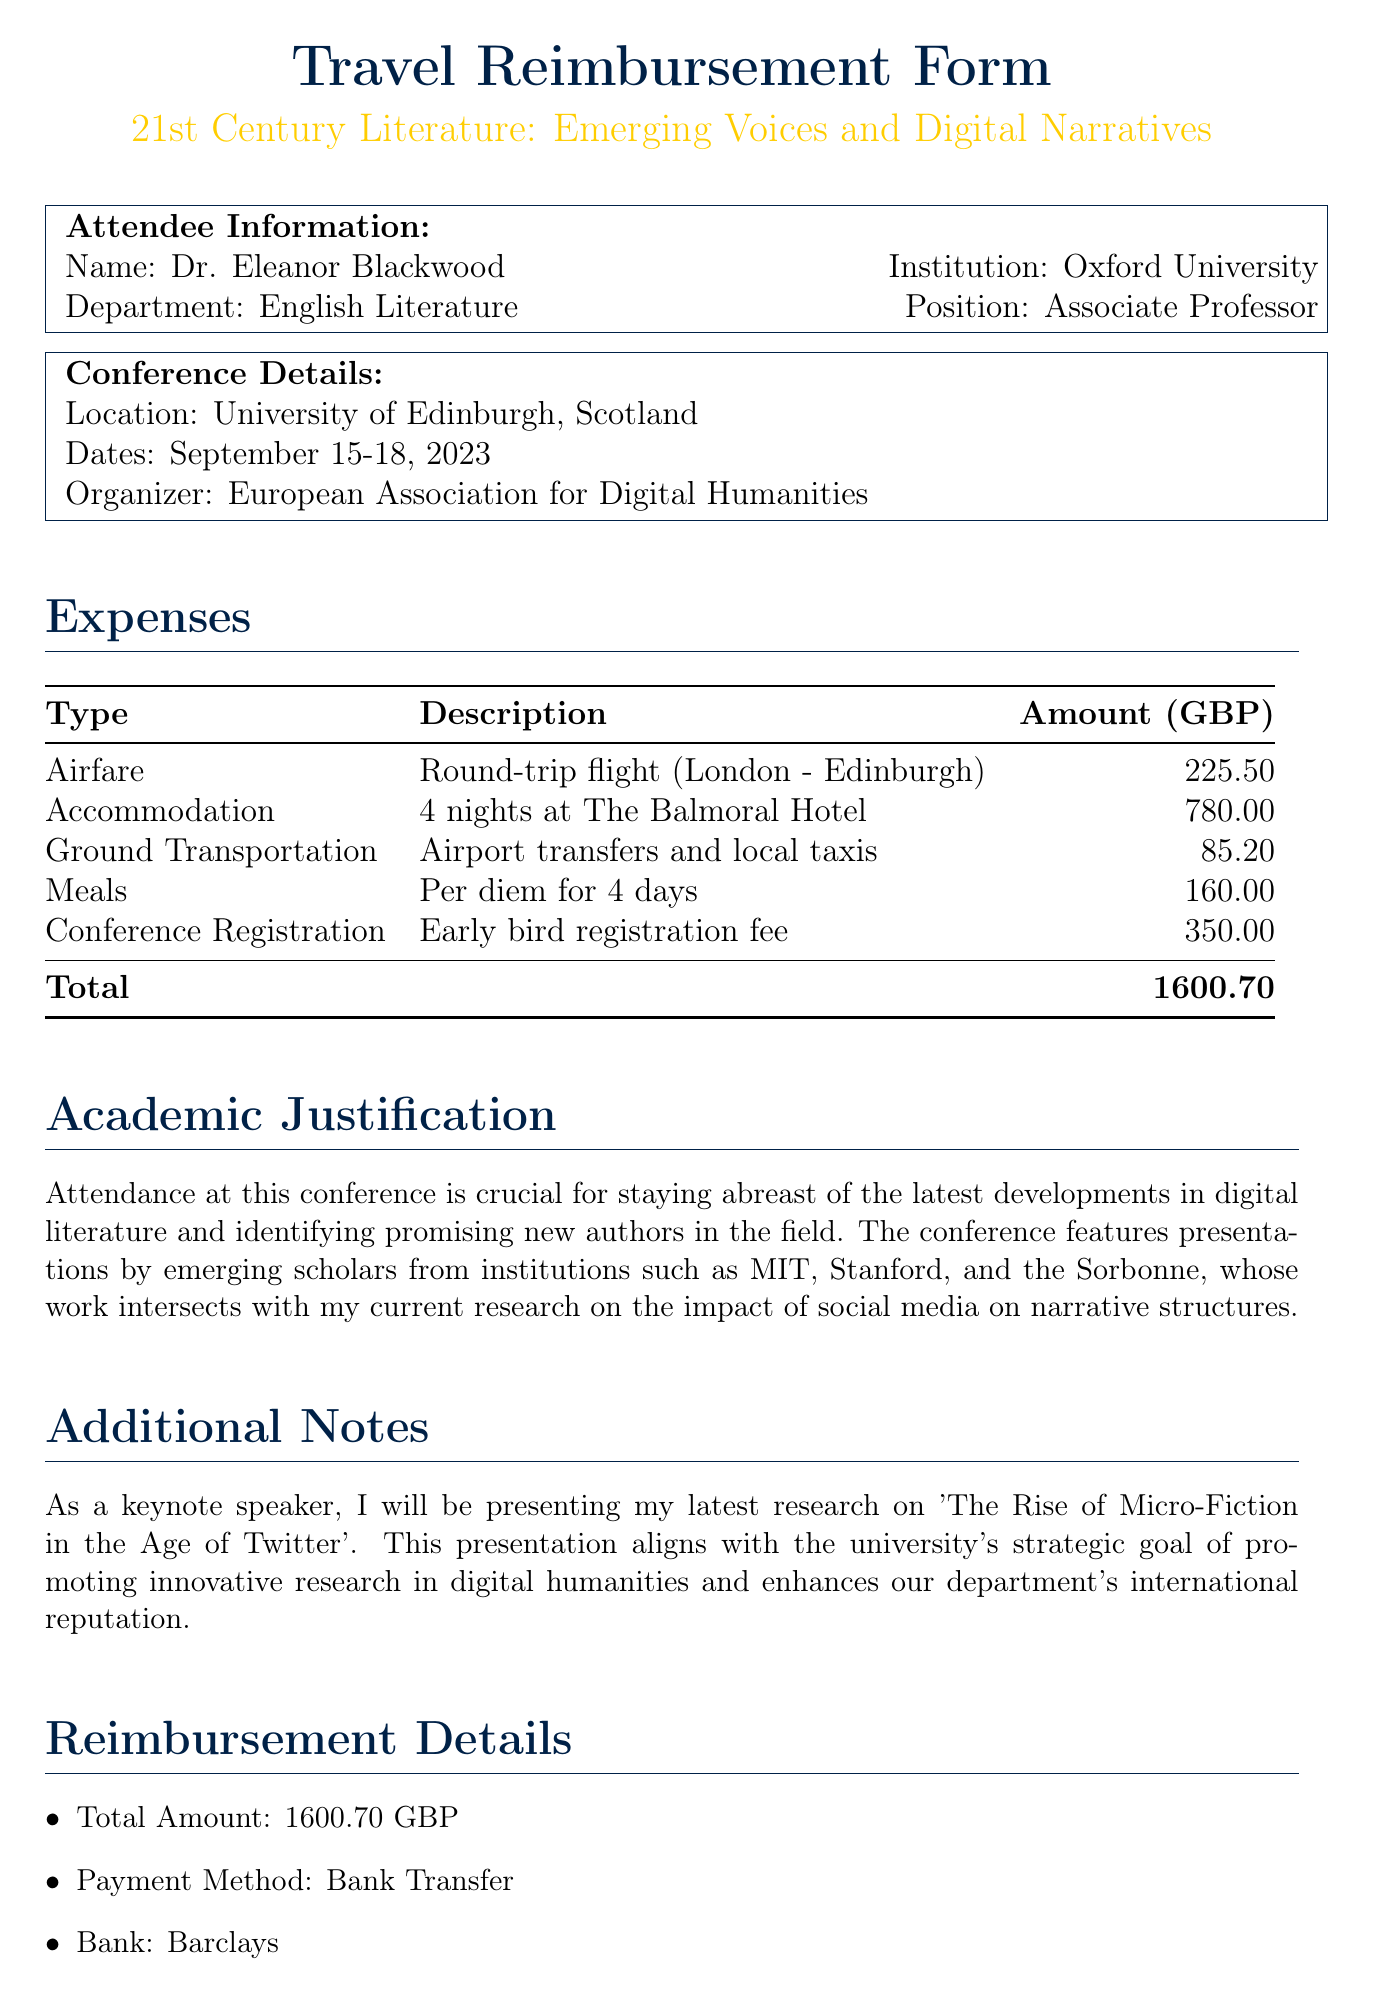What is the name of the conference? The conference is named "21st Century Literature: Emerging Voices and Digital Narratives."
Answer: 21st Century Literature: Emerging Voices and Digital Narratives Who is the attendee? The attendee is Dr. Eleanor Blackwood.
Answer: Dr. Eleanor Blackwood What is the total amount for reimbursement? The total amount is the sum of all travel expenses outlined in the document, which is £1600.70.
Answer: 1600.70 GBP How many nights did Dr. Blackwood stay at the hotel? The document states that Dr. Blackwood stayed for 4 nights at The Balmoral Hotel.
Answer: 4 nights What is Dr. Blackwood's position? The document describes Dr. Blackwood as an Associate Professor.
Answer: Associate Professor Which bank will the payment be transferred to? The document specifies that the payment method is via bank transfer to Barclays.
Answer: Barclays What is the primary academic justification for attending the conference? Dr. Blackwood mentions staying abreast of developments in digital literature and identifying new authors.
Answer: Latest developments in digital literature Who approved the reimbursement? The approval chain includes Prof. Jonathan Hargreaves and Dr. Samantha Wilkins.
Answer: Prof. Jonathan Hargreaves, Dr. Samantha Wilkins What type of transportation expenses were claimed? The document lists ground transportation expenses including airport transfers and local taxis.
Answer: Airport transfers and local taxis 